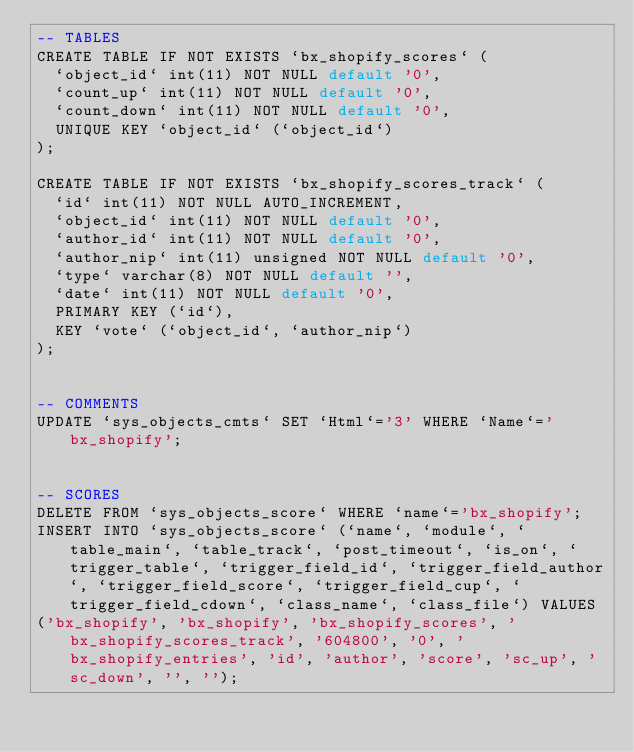<code> <loc_0><loc_0><loc_500><loc_500><_SQL_>-- TABLES
CREATE TABLE IF NOT EXISTS `bx_shopify_scores` (
  `object_id` int(11) NOT NULL default '0',
  `count_up` int(11) NOT NULL default '0',
  `count_down` int(11) NOT NULL default '0',
  UNIQUE KEY `object_id` (`object_id`)
);

CREATE TABLE IF NOT EXISTS `bx_shopify_scores_track` (
  `id` int(11) NOT NULL AUTO_INCREMENT,
  `object_id` int(11) NOT NULL default '0',
  `author_id` int(11) NOT NULL default '0',
  `author_nip` int(11) unsigned NOT NULL default '0',
  `type` varchar(8) NOT NULL default '',
  `date` int(11) NOT NULL default '0',
  PRIMARY KEY (`id`),
  KEY `vote` (`object_id`, `author_nip`)
);


-- COMMENTS
UPDATE `sys_objects_cmts` SET `Html`='3' WHERE `Name`='bx_shopify';


-- SCORES
DELETE FROM `sys_objects_score` WHERE `name`='bx_shopify';
INSERT INTO `sys_objects_score` (`name`, `module`, `table_main`, `table_track`, `post_timeout`, `is_on`, `trigger_table`, `trigger_field_id`, `trigger_field_author`, `trigger_field_score`, `trigger_field_cup`, `trigger_field_cdown`, `class_name`, `class_file`) VALUES 
('bx_shopify', 'bx_shopify', 'bx_shopify_scores', 'bx_shopify_scores_track', '604800', '0', 'bx_shopify_entries', 'id', 'author', 'score', 'sc_up', 'sc_down', '', '');
</code> 